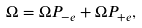Convert formula to latex. <formula><loc_0><loc_0><loc_500><loc_500>\Omega = \Omega P _ { - e } + \Omega P _ { + e } ,</formula> 